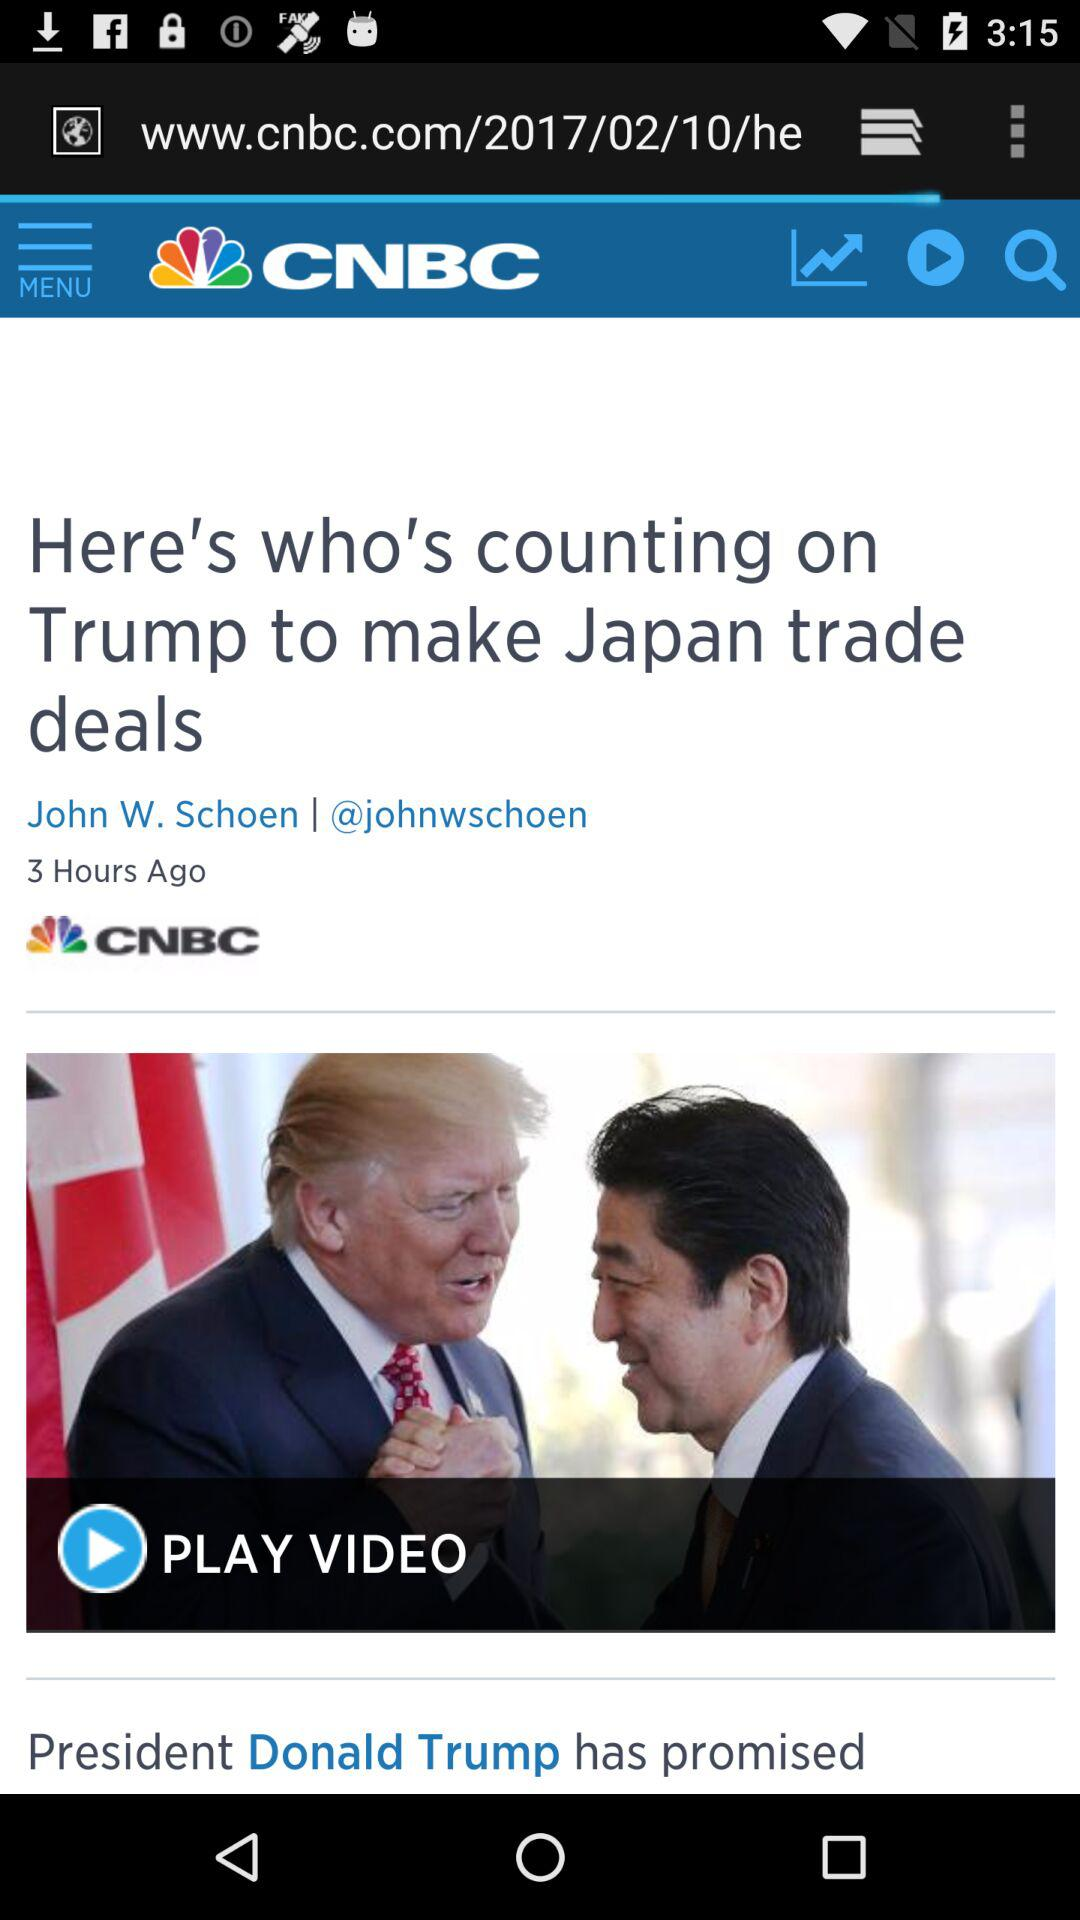Who is the writer of the news? The writer of the news is John W. Schoen. 